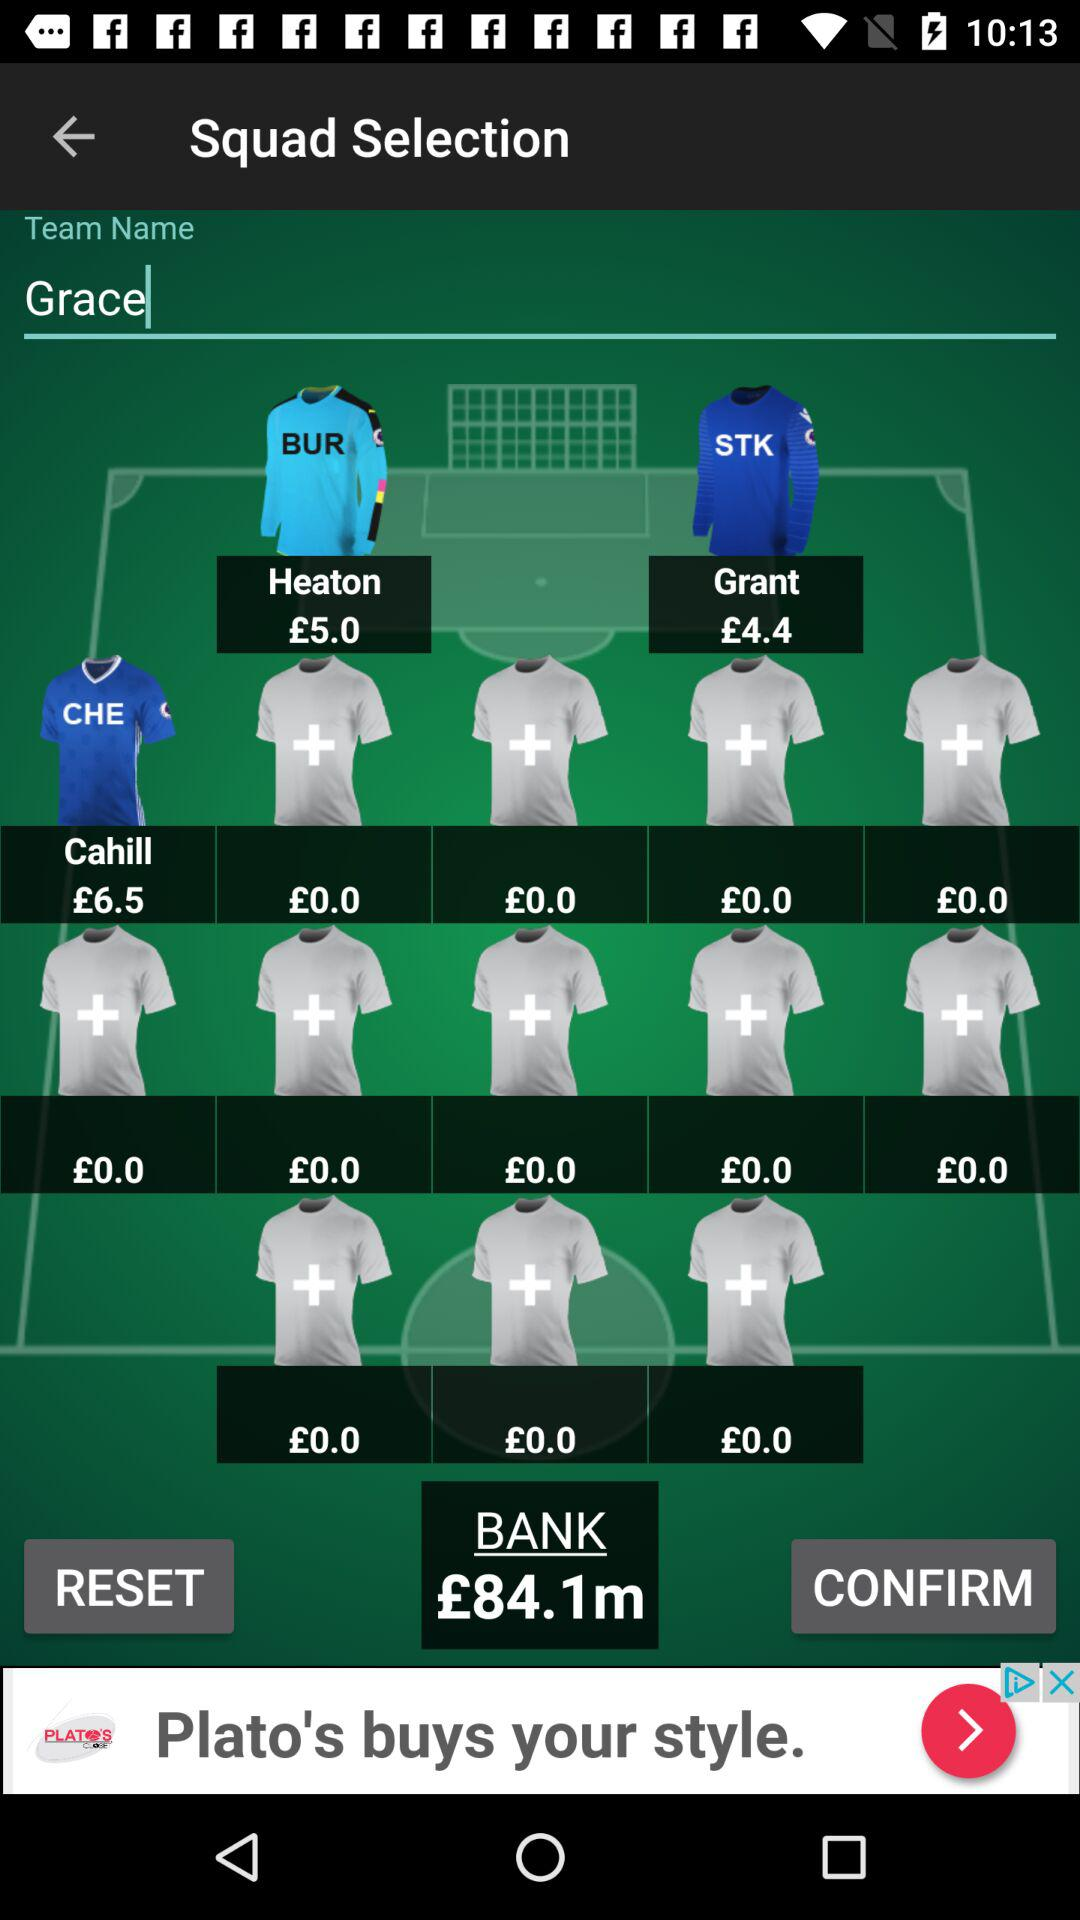How much does Grant cost? Grant's cost is £4.4. 